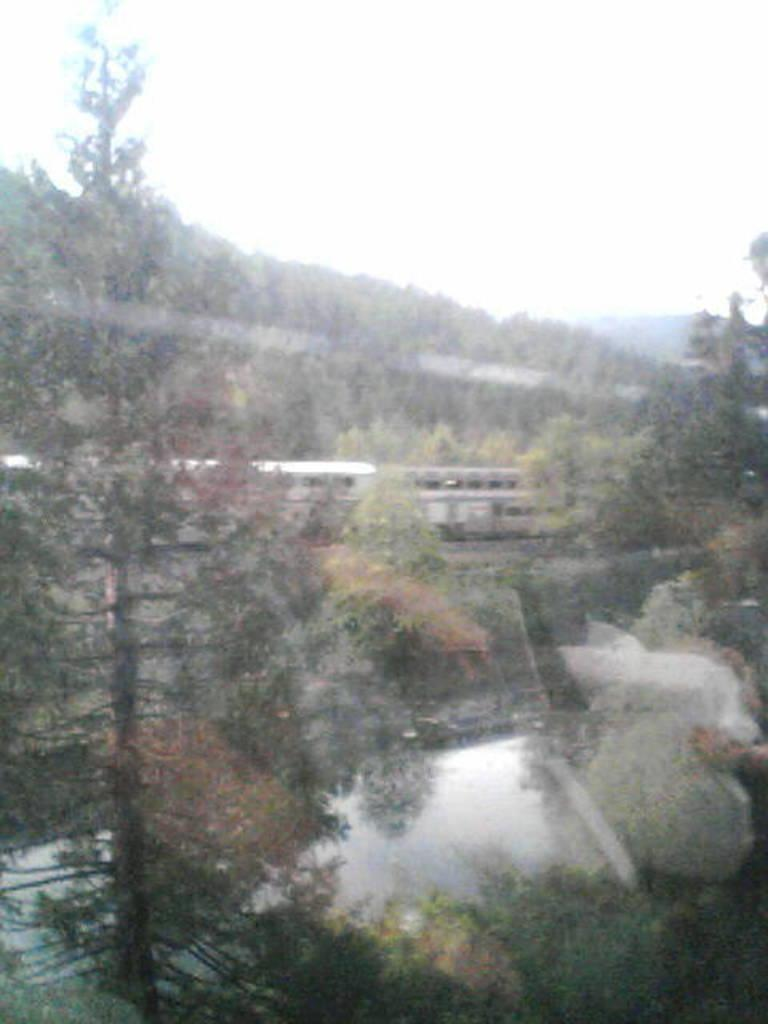What type of structure can be seen in the image? There is a bridge in the image. What mode of transportation is on the bridge? There is a train on the track in the image. What type of natural environment is visible in the image? Trees and hills are present in the image. What is visible at the top of the image? The sky is visible at the top of the image. What is present at the bottom of the image? Water is present at the bottom of the image. What is the representative size of the train compared to the bridge in the image? The provided facts do not include any information about the size of the train or the bridge, so it is impossible to determine their relative sizes in the image. 